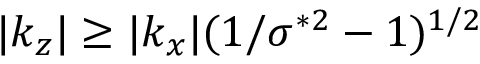<formula> <loc_0><loc_0><loc_500><loc_500>| k _ { z } | \geq | k _ { x } | ( 1 / \sigma ^ { * 2 } - 1 ) ^ { 1 / 2 }</formula> 